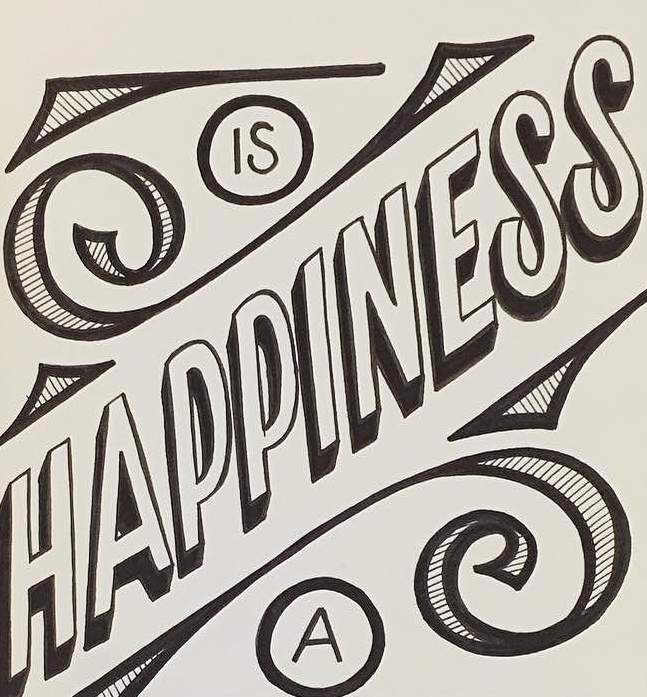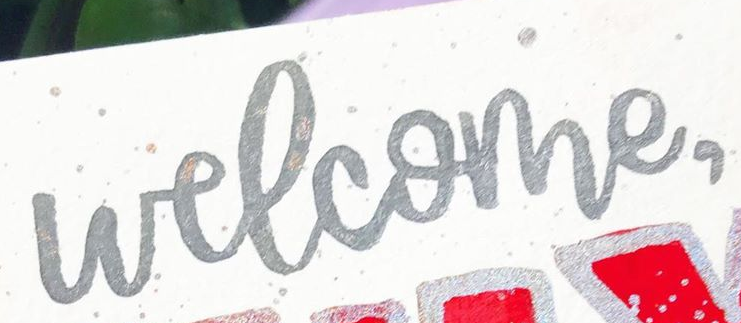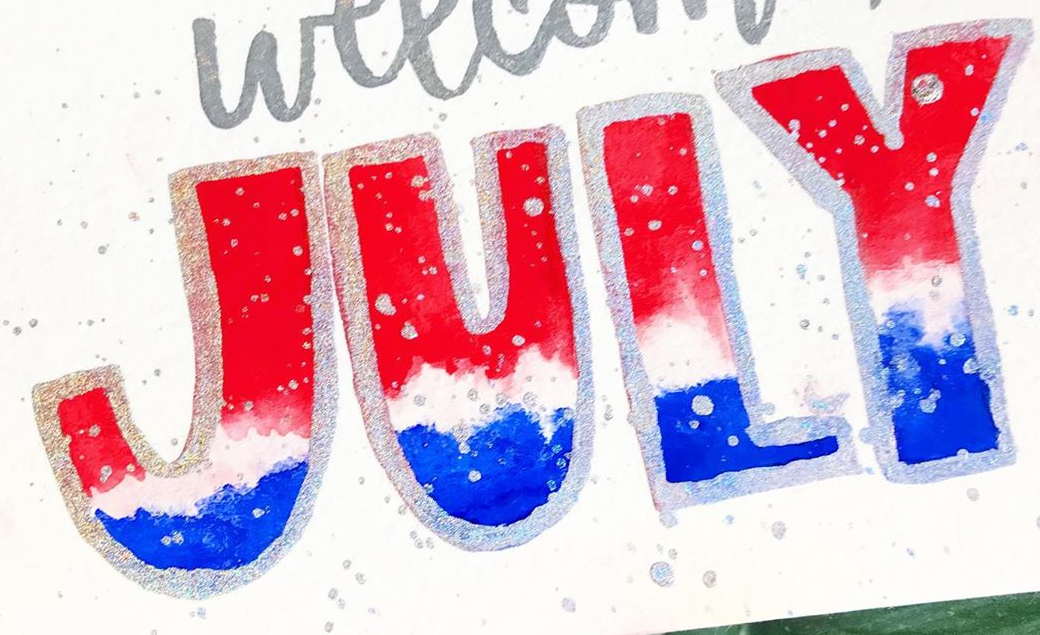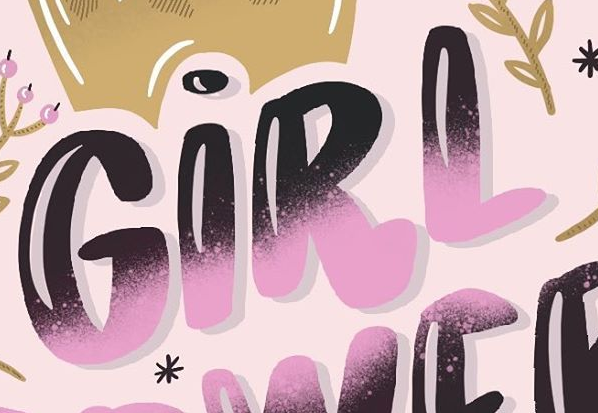What words can you see in these images in sequence, separated by a semicolon? HAPPINESS; welcome,; JULY; GIRL 